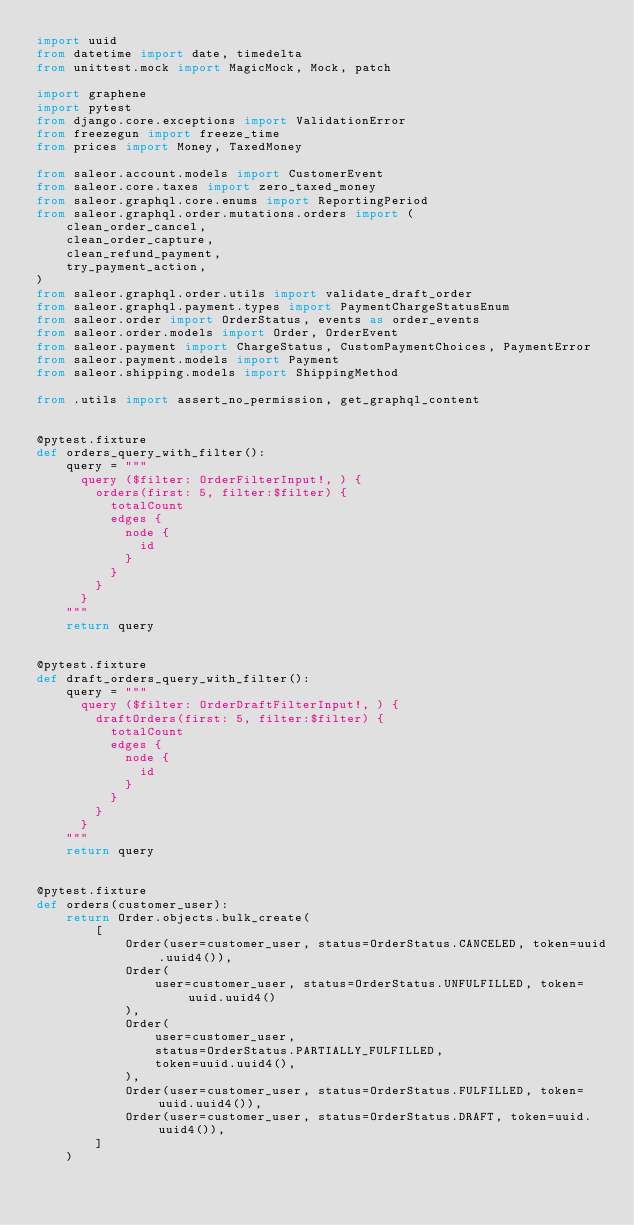<code> <loc_0><loc_0><loc_500><loc_500><_Python_>import uuid
from datetime import date, timedelta
from unittest.mock import MagicMock, Mock, patch

import graphene
import pytest
from django.core.exceptions import ValidationError
from freezegun import freeze_time
from prices import Money, TaxedMoney

from saleor.account.models import CustomerEvent
from saleor.core.taxes import zero_taxed_money
from saleor.graphql.core.enums import ReportingPeriod
from saleor.graphql.order.mutations.orders import (
    clean_order_cancel,
    clean_order_capture,
    clean_refund_payment,
    try_payment_action,
)
from saleor.graphql.order.utils import validate_draft_order
from saleor.graphql.payment.types import PaymentChargeStatusEnum
from saleor.order import OrderStatus, events as order_events
from saleor.order.models import Order, OrderEvent
from saleor.payment import ChargeStatus, CustomPaymentChoices, PaymentError
from saleor.payment.models import Payment
from saleor.shipping.models import ShippingMethod

from .utils import assert_no_permission, get_graphql_content


@pytest.fixture
def orders_query_with_filter():
    query = """
      query ($filter: OrderFilterInput!, ) {
        orders(first: 5, filter:$filter) {
          totalCount
          edges {
            node {
              id
            }
          }
        }
      }
    """
    return query


@pytest.fixture
def draft_orders_query_with_filter():
    query = """
      query ($filter: OrderDraftFilterInput!, ) {
        draftOrders(first: 5, filter:$filter) {
          totalCount
          edges {
            node {
              id
            }
          }
        }
      }
    """
    return query


@pytest.fixture
def orders(customer_user):
    return Order.objects.bulk_create(
        [
            Order(user=customer_user, status=OrderStatus.CANCELED, token=uuid.uuid4()),
            Order(
                user=customer_user, status=OrderStatus.UNFULFILLED, token=uuid.uuid4()
            ),
            Order(
                user=customer_user,
                status=OrderStatus.PARTIALLY_FULFILLED,
                token=uuid.uuid4(),
            ),
            Order(user=customer_user, status=OrderStatus.FULFILLED, token=uuid.uuid4()),
            Order(user=customer_user, status=OrderStatus.DRAFT, token=uuid.uuid4()),
        ]
    )

</code> 